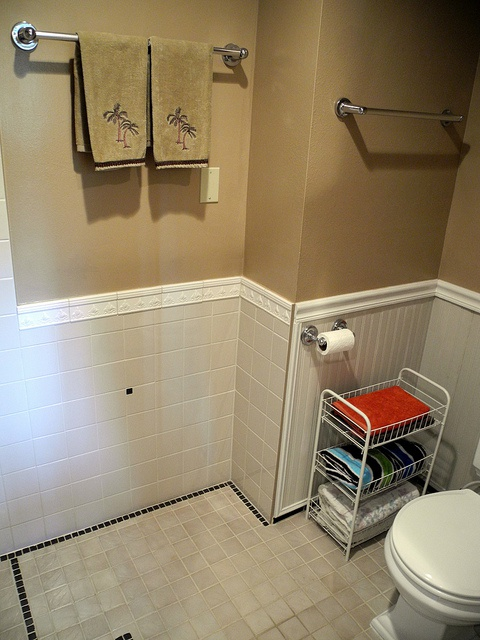Describe the objects in this image and their specific colors. I can see a toilet in gray, beige, and darkgray tones in this image. 